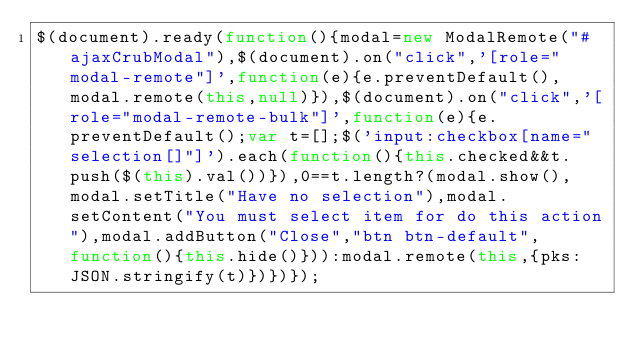Convert code to text. <code><loc_0><loc_0><loc_500><loc_500><_JavaScript_>$(document).ready(function(){modal=new ModalRemote("#ajaxCrubModal"),$(document).on("click",'[role="modal-remote"]',function(e){e.preventDefault(),modal.remote(this,null)}),$(document).on("click",'[role="modal-remote-bulk"]',function(e){e.preventDefault();var t=[];$('input:checkbox[name="selection[]"]').each(function(){this.checked&&t.push($(this).val())}),0==t.length?(modal.show(),modal.setTitle("Have no selection"),modal.setContent("You must select item for do this action"),modal.addButton("Close","btn btn-default",function(){this.hide()})):modal.remote(this,{pks:JSON.stringify(t)})})});</code> 